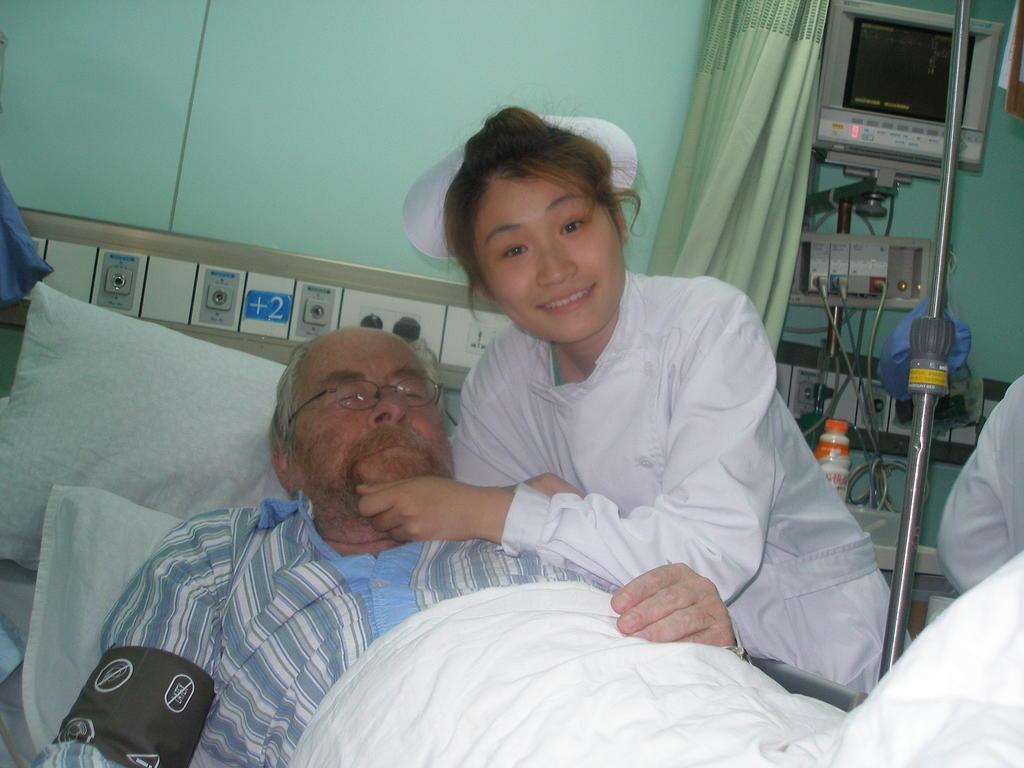Can you describe this image briefly? In this image we can see two persons, among them one person is lying on the bed, in the background, we can see the wall, curtain, tv, switchboard, and some other objects, also we can see the pillows and a pole. 